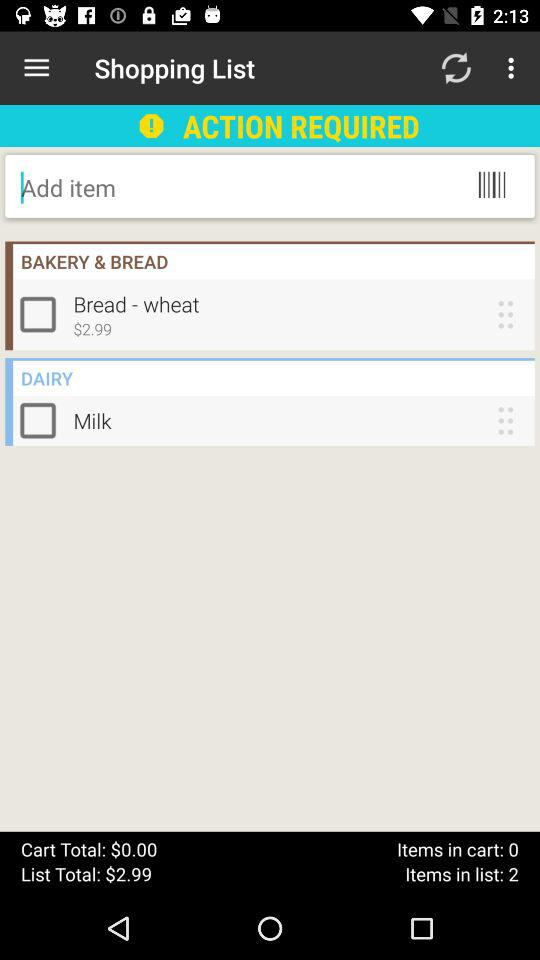What is the total cart amount? The total cart amount is $0. 